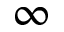<formula> <loc_0><loc_0><loc_500><loc_500>\infty</formula> 